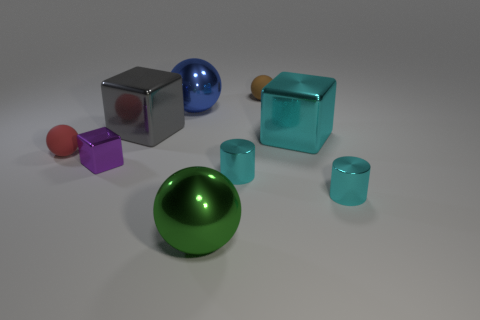Is there a green object of the same shape as the tiny purple metallic object?
Provide a short and direct response. No. There is a blue metal ball that is behind the big cyan thing; does it have the same size as the cyan thing behind the red ball?
Give a very brief answer. Yes. Are there more cyan metallic blocks than objects?
Give a very brief answer. No. What number of big blue cubes are the same material as the blue sphere?
Your response must be concise. 0. Is the red matte thing the same shape as the large green metal object?
Provide a succinct answer. Yes. How big is the cyan cylinder that is on the left side of the tiny cyan metallic cylinder right of the cyan metallic object behind the small block?
Your response must be concise. Small. Are there any big blue shiny things that are on the left side of the sphere that is left of the purple metallic block?
Provide a short and direct response. No. How many small cyan cylinders are in front of the matte sphere on the left side of the big green object to the right of the big gray shiny block?
Your answer should be very brief. 2. There is a metallic object that is both on the right side of the green ball and to the left of the brown ball; what color is it?
Offer a very short reply. Cyan. How many other small blocks are the same color as the tiny cube?
Make the answer very short. 0. 